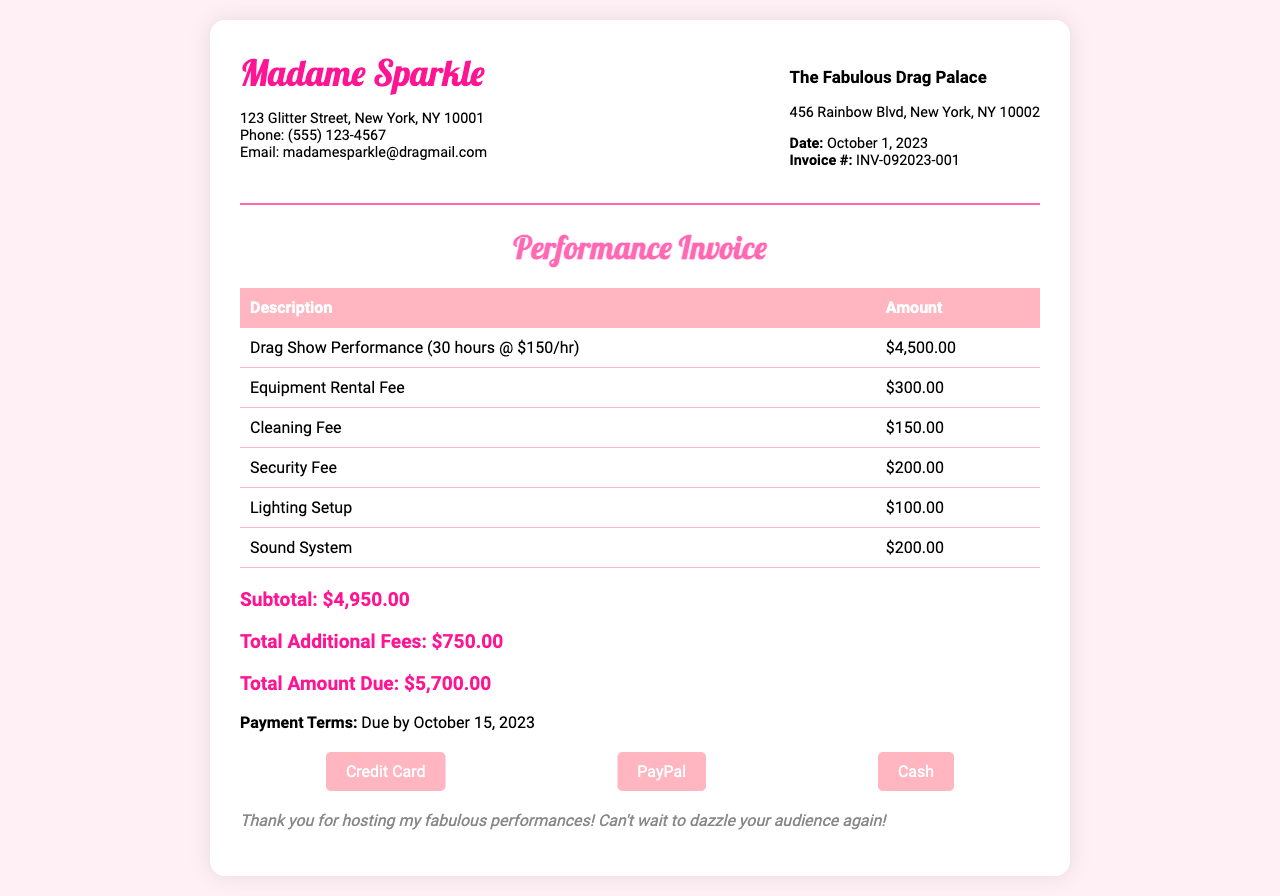what is the total amount due? The total amount due is presented in the invoice as the final amount to be paid, which is $5,700.00.
Answer: $5,700.00 what is the hourly rate for the drag show performance? The hourly rate is indicated in the invoice as $150 per hour for the drag show performance.
Answer: $150 how many hours were billed for the drag show performance? The number of hours billed is specified as 30 hours in the invoice.
Answer: 30 hours what is the due date for the payment? The due date for the payment is clearly stated in the invoice as October 15, 2023.
Answer: October 15, 2023 what are the total additional fees? The total additional fees are listed in the invoice, summing up to $750.00.
Answer: $750.00 what is the address of The Fabulous Drag Palace? The address is found in the invoice and is 456 Rainbow Blvd, New York, NY 10002.
Answer: 456 Rainbow Blvd, New York, NY 10002 what fee is listed for equipment rental? The fee for equipment rental is explicitly mentioned in the invoice as $300.00.
Answer: $300.00 what is the cleaning fee charged in the invoice? The cleaning fee is specified in the invoice as $150.00.
Answer: $150.00 who is the invoice issued by? The invoice is issued by Madame Sparkle, as indicated at the top of the document.
Answer: Madame Sparkle 